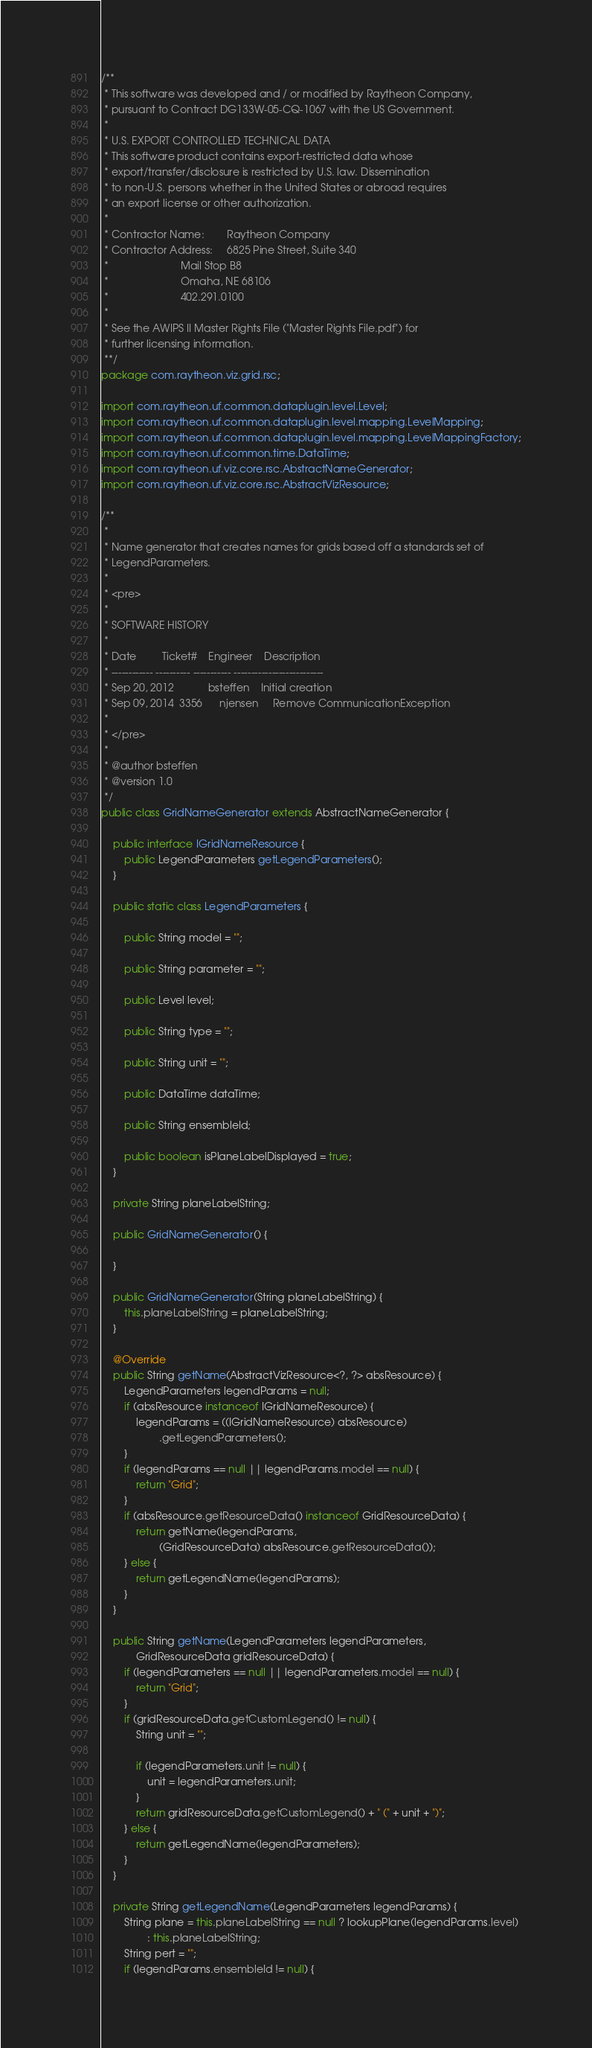Convert code to text. <code><loc_0><loc_0><loc_500><loc_500><_Java_>/**
 * This software was developed and / or modified by Raytheon Company,
 * pursuant to Contract DG133W-05-CQ-1067 with the US Government.
 * 
 * U.S. EXPORT CONTROLLED TECHNICAL DATA
 * This software product contains export-restricted data whose
 * export/transfer/disclosure is restricted by U.S. law. Dissemination
 * to non-U.S. persons whether in the United States or abroad requires
 * an export license or other authorization.
 * 
 * Contractor Name:        Raytheon Company
 * Contractor Address:     6825 Pine Street, Suite 340
 *                         Mail Stop B8
 *                         Omaha, NE 68106
 *                         402.291.0100
 * 
 * See the AWIPS II Master Rights File ("Master Rights File.pdf") for
 * further licensing information.
 **/
package com.raytheon.viz.grid.rsc;

import com.raytheon.uf.common.dataplugin.level.Level;
import com.raytheon.uf.common.dataplugin.level.mapping.LevelMapping;
import com.raytheon.uf.common.dataplugin.level.mapping.LevelMappingFactory;
import com.raytheon.uf.common.time.DataTime;
import com.raytheon.uf.viz.core.rsc.AbstractNameGenerator;
import com.raytheon.uf.viz.core.rsc.AbstractVizResource;

/**
 * 
 * Name generator that creates names for grids based off a standards set of
 * LegendParameters.
 * 
 * <pre>
 * 
 * SOFTWARE HISTORY
 * 
 * Date         Ticket#    Engineer    Description
 * ------------ ---------- ----------- --------------------------
 * Sep 20, 2012            bsteffen    Initial creation
 * Sep 09, 2014  3356      njensen     Remove CommunicationException
 * 
 * </pre>
 * 
 * @author bsteffen
 * @version 1.0
 */
public class GridNameGenerator extends AbstractNameGenerator {

    public interface IGridNameResource {
        public LegendParameters getLegendParameters();
    }

    public static class LegendParameters {

        public String model = "";

        public String parameter = "";

        public Level level;

        public String type = "";

        public String unit = "";

        public DataTime dataTime;

        public String ensembleId;

        public boolean isPlaneLabelDisplayed = true;
    }

    private String planeLabelString;

    public GridNameGenerator() {

    }

    public GridNameGenerator(String planeLabelString) {
        this.planeLabelString = planeLabelString;
    }

    @Override
    public String getName(AbstractVizResource<?, ?> absResource) {
        LegendParameters legendParams = null;
        if (absResource instanceof IGridNameResource) {
            legendParams = ((IGridNameResource) absResource)
                    .getLegendParameters();
        }
        if (legendParams == null || legendParams.model == null) {
            return "Grid";
        }
        if (absResource.getResourceData() instanceof GridResourceData) {
            return getName(legendParams,
                    (GridResourceData) absResource.getResourceData());
        } else {
            return getLegendName(legendParams);
        }
    }

    public String getName(LegendParameters legendParameters,
            GridResourceData gridResourceData) {
        if (legendParameters == null || legendParameters.model == null) {
            return "Grid";
        }
        if (gridResourceData.getCustomLegend() != null) {
            String unit = "";

            if (legendParameters.unit != null) {
                unit = legendParameters.unit;
            }
            return gridResourceData.getCustomLegend() + " (" + unit + ")";
        } else {
            return getLegendName(legendParameters);
        }
    }

    private String getLegendName(LegendParameters legendParams) {
        String plane = this.planeLabelString == null ? lookupPlane(legendParams.level)
                : this.planeLabelString;
        String pert = "";
        if (legendParams.ensembleId != null) {</code> 